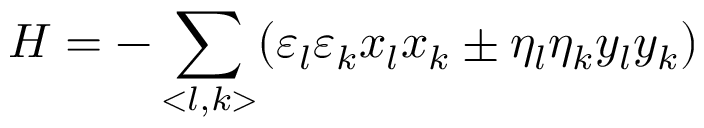<formula> <loc_0><loc_0><loc_500><loc_500>H = - \sum _ { < l , k > } ( \varepsilon _ { l } \varepsilon _ { k } x _ { l } x _ { k } \pm \eta _ { l } \eta _ { k } y _ { l } y _ { k } )</formula> 